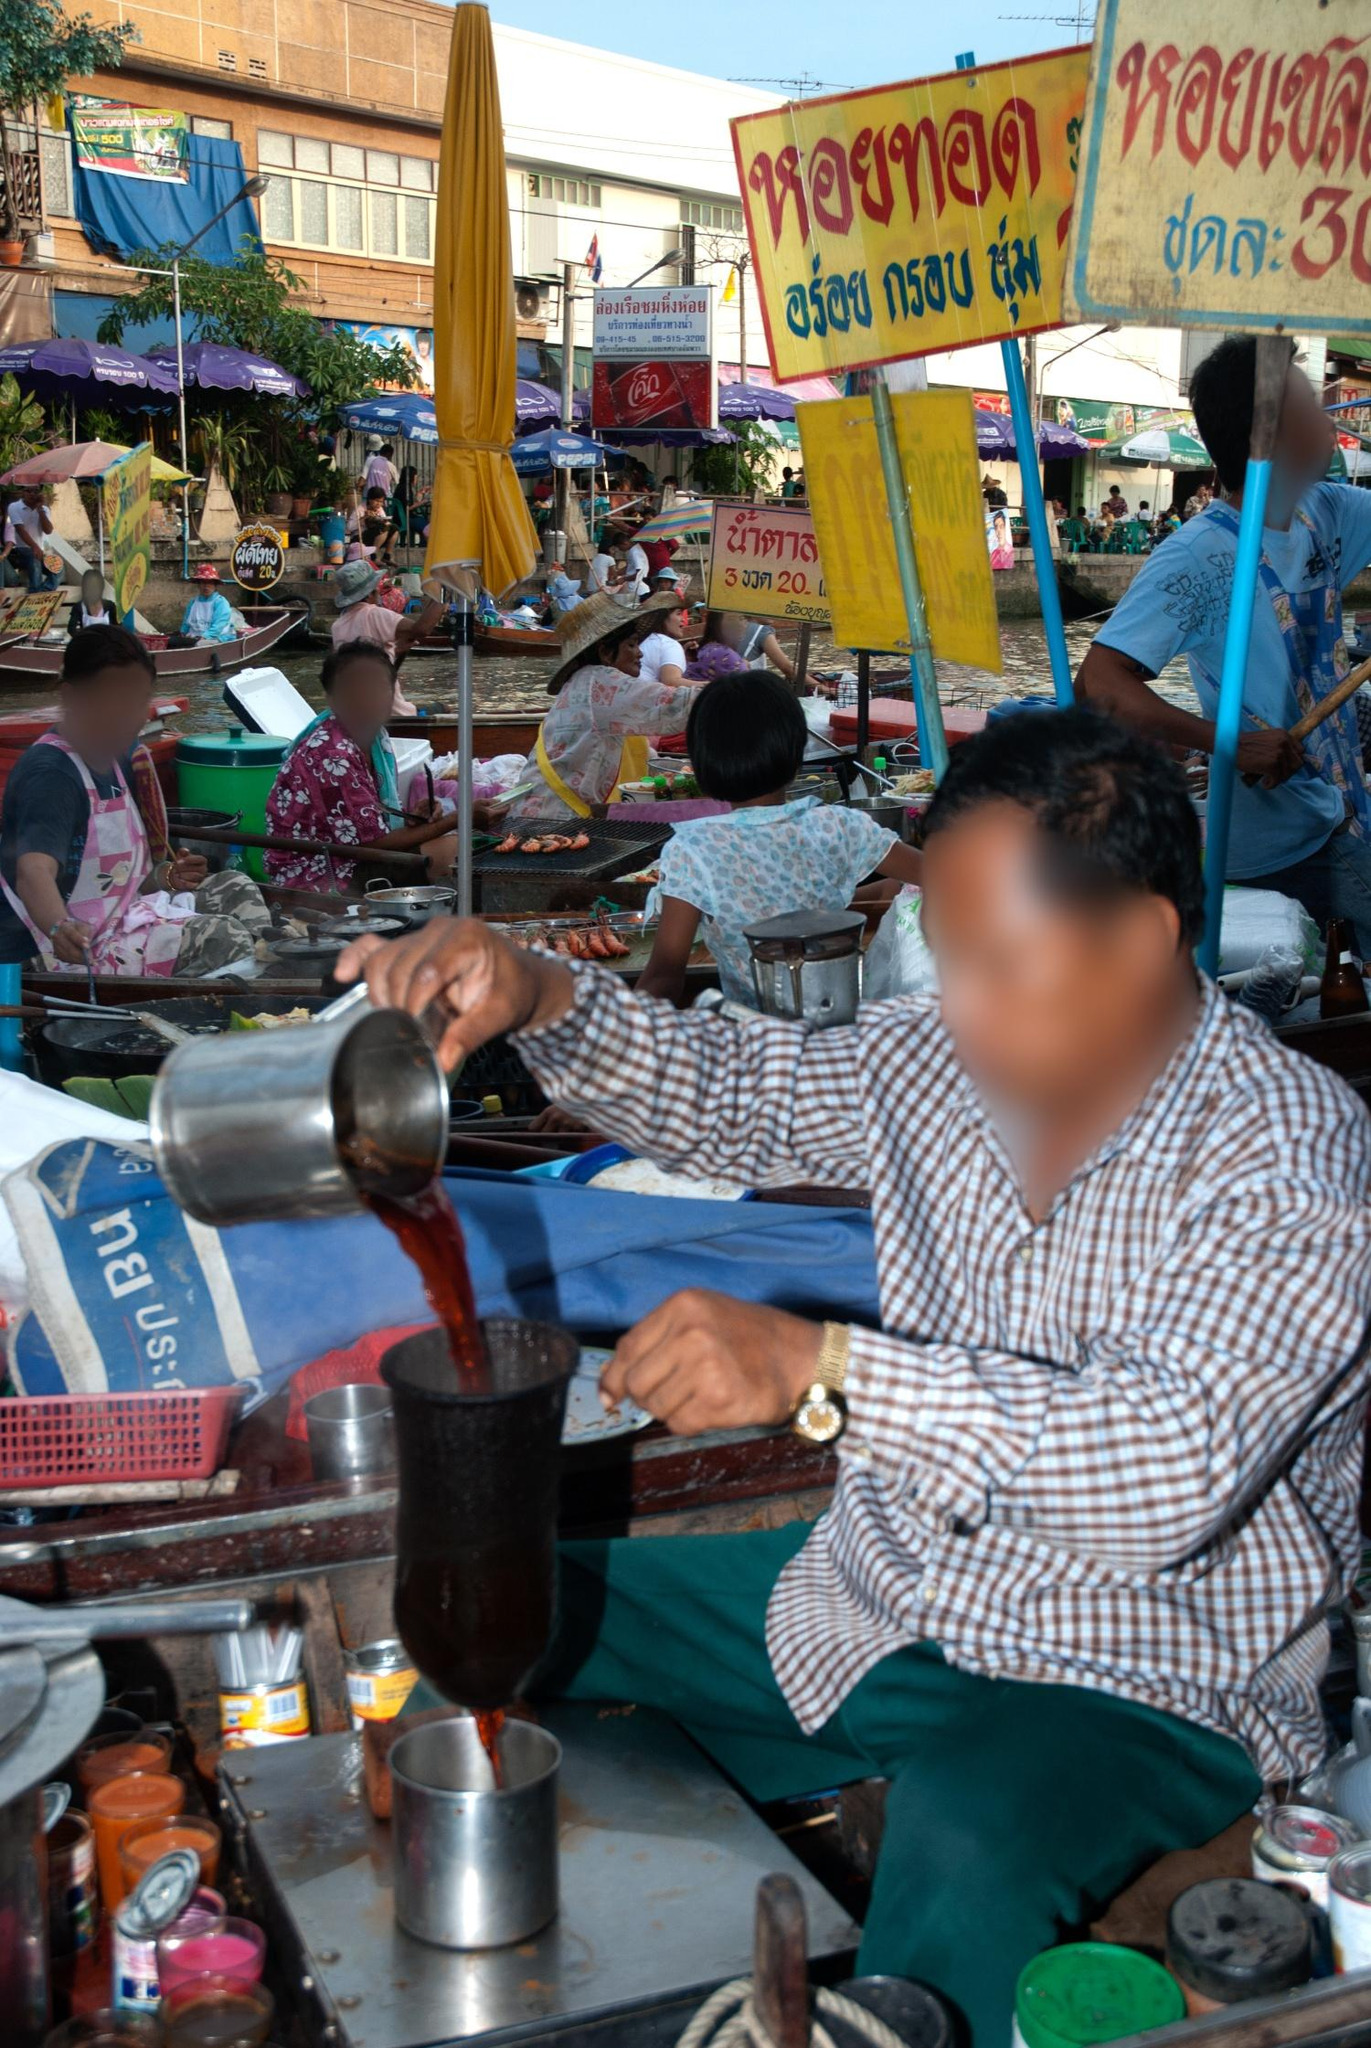Can you create a short story based on this image? In the heart of Thailand’s floating market, a humble vendor named Somchai poured his soul, just like the honey drink he carefully mixed each day. The little stall, adorned with colorful bottles and trinkets, was his pride and joy. Tourists and locals alike flocked to taste his renowned honey drink, each cup a blend of traditional flavors and Somchai’s secret ingredient - a dash of love and tradition. The market buzzed around him, but within his stall, time slowed as he greeted every customer with a warm smile, serving not just a drink but a piece of his legacy. Little did passersby know, that every evening as the sun dipped low, Somchai would whisper a silent prayer of gratitude for another bustling day, dreaming of the rich traditions he kept alive. How long have markets like this existed in Thailand? Floating markets have been an integral part of Thailand’s cultural and economic fabric for centuries. Originating as early as the Ayutthaya period (1350-1767), these markets developed primarily due to the country's canal networks, which were essential for transportation and commerce. Over time, floating markets have evolved, blending tradition with tourism, yet they still remain a vital component of Thai community life and heritage. The bustling scenes, vibrant goods, and sense of camaraderie experienced at these markets offer a living link to the past, showcasing the enduring spirit of Thai culture. If this market were to come alive at night, what would it look like, and how would it sound? As dusk settles over the floating market, a transformation begins. Lanterns flicker to life, casting a warm, golden glow over the boats and stalls, their reflections dancing on the water’s surface. The once colorful sights blend into an enchanting tapestry of lights, shadows, and soft murmurs. Vendors’ chatter turns into gentle banter, punctuated by laughter and the occasional bark of a vendor enticing late-night visitors. The aroma of grilled skewers and steaming soups lingers in the cool evening air, mingling with the scent of blooming jasmine. A traditional Thai musician might strum a soothing melody on a khim, adding a serene backdrop to the hum of market activities. The market, bathed in the mellow embrace of evening, offers a magical, almost nostalgic atmosphere, captivating all who experience its nocturnal charm. 